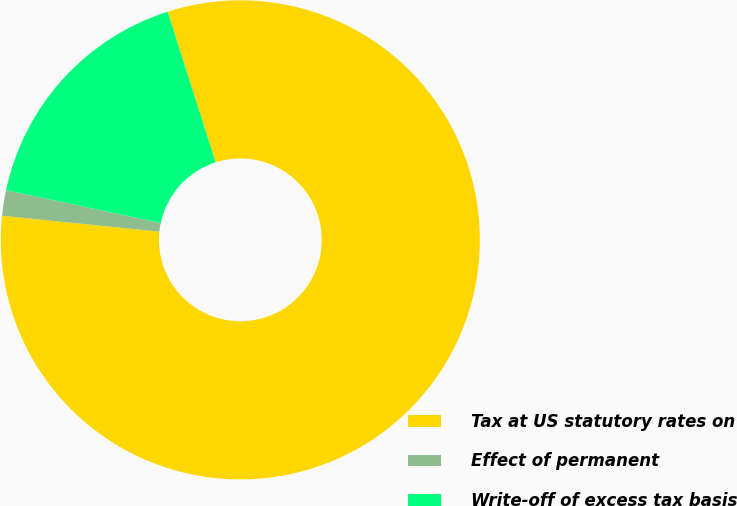Convert chart to OTSL. <chart><loc_0><loc_0><loc_500><loc_500><pie_chart><fcel>Tax at US statutory rates on<fcel>Effect of permanent<fcel>Write-off of excess tax basis<nl><fcel>81.52%<fcel>1.72%<fcel>16.76%<nl></chart> 